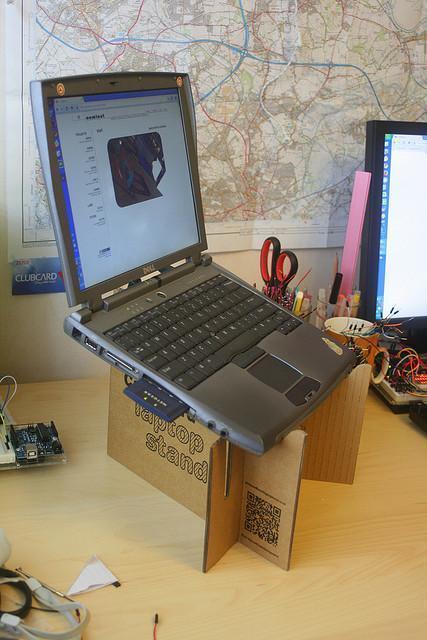How many tvs can be seen?
Give a very brief answer. 2. 